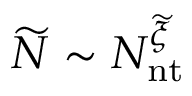Convert formula to latex. <formula><loc_0><loc_0><loc_500><loc_500>\widetilde { N } \sim N _ { n t } ^ { \widetilde { \xi } }</formula> 